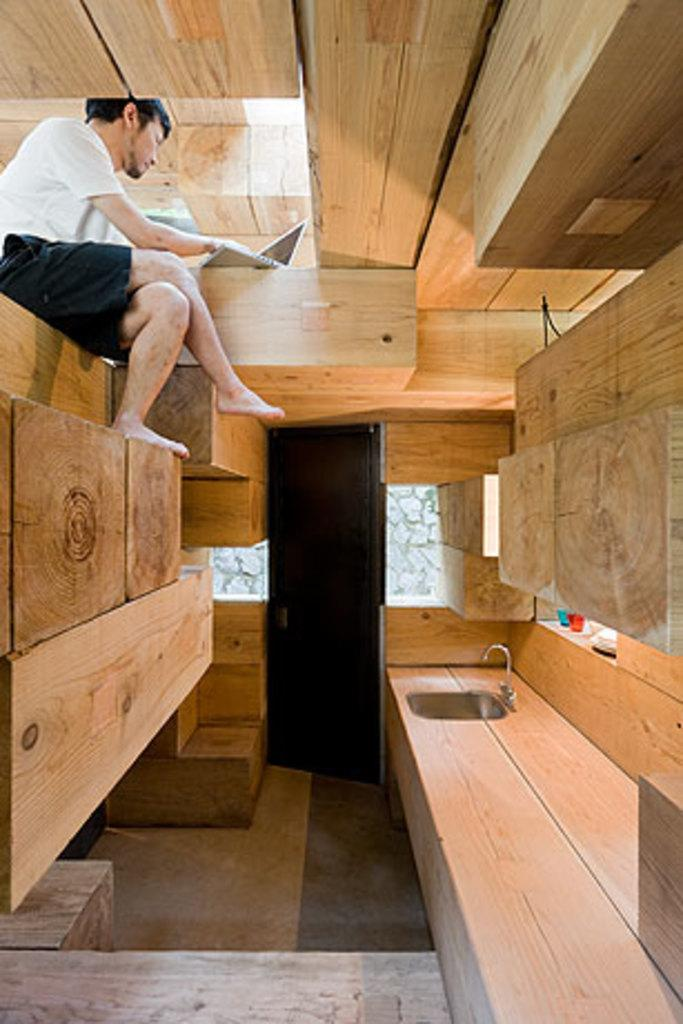Who is present in the image? There is a man in the image. What electronic device can be seen in the image? There is a laptop in the image. What part of the room is visible in the image? The floor is visible in the image. What architectural feature is present in the image? There is a door in the image. What type of appliance is in the image? There is a sink in the image. What part of the sink is visible in the image? There is a tap in the image. What type of material is used for some objects in the image? There are wooden objects in the image. What type of gold potato can be seen in the image? There is no potato, gold, or any combination of the two present in the image. 